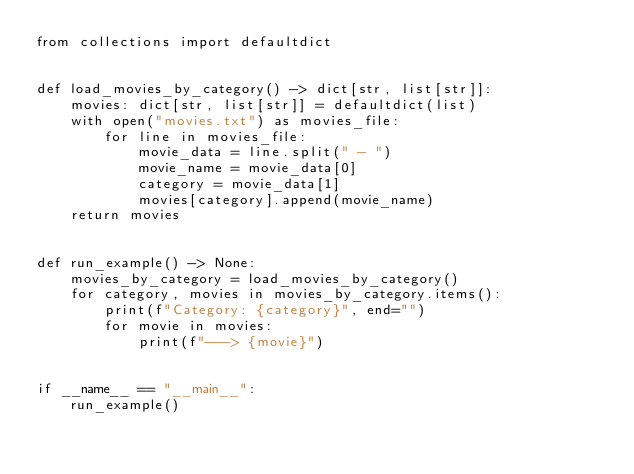Convert code to text. <code><loc_0><loc_0><loc_500><loc_500><_Python_>from collections import defaultdict


def load_movies_by_category() -> dict[str, list[str]]:
    movies: dict[str, list[str]] = defaultdict(list)
    with open("movies.txt") as movies_file:
        for line in movies_file:
            movie_data = line.split(" - ")
            movie_name = movie_data[0]
            category = movie_data[1]
            movies[category].append(movie_name)
    return movies


def run_example() -> None:
    movies_by_category = load_movies_by_category()
    for category, movies in movies_by_category.items():
        print(f"Category: {category}", end="")
        for movie in movies:
            print(f"---> {movie}")


if __name__ == "__main__":
    run_example()
</code> 